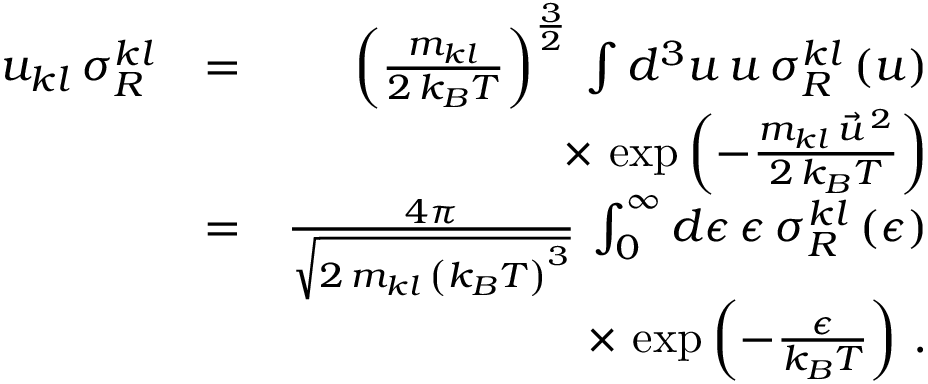<formula> <loc_0><loc_0><loc_500><loc_500>\begin{array} { r l r } { u _ { k l } \, \sigma _ { R } ^ { k l } } & { = } & { \left ( \frac { m _ { k l } } { 2 \, k _ { B } T } \right ) ^ { \frac { 3 } { 2 } } \, \int d ^ { 3 } u \, u \, \sigma _ { R } ^ { k l } \left ( u \right ) } \\ & { \times \, \exp \left ( - \frac { m _ { k l } \, \vec { u } ^ { \, 2 } } { 2 \, k _ { B } T } \right ) } \\ & { = } & { \frac { 4 \pi } { \sqrt { 2 \, m _ { k l } \, \left ( k _ { B } T \right ) ^ { 3 } } } \, \int _ { 0 } ^ { \infty } d \epsilon \, \epsilon \, \sigma _ { R } ^ { k l } \left ( \epsilon \right ) } \\ & { \times \, \exp \left ( - \frac { \epsilon } { k _ { B } T } \right ) \, . } \end{array}</formula> 